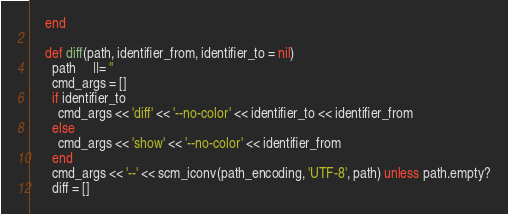<code> <loc_0><loc_0><loc_500><loc_500><_Ruby_>    end

    def diff(path, identifier_from, identifier_to = nil)
      path     ||= ''
      cmd_args = []
      if identifier_to
        cmd_args << 'diff' << '--no-color' << identifier_to << identifier_from
      else
        cmd_args << 'show' << '--no-color' << identifier_from
      end
      cmd_args << '--' << scm_iconv(path_encoding, 'UTF-8', path) unless path.empty?
      diff = []</code> 